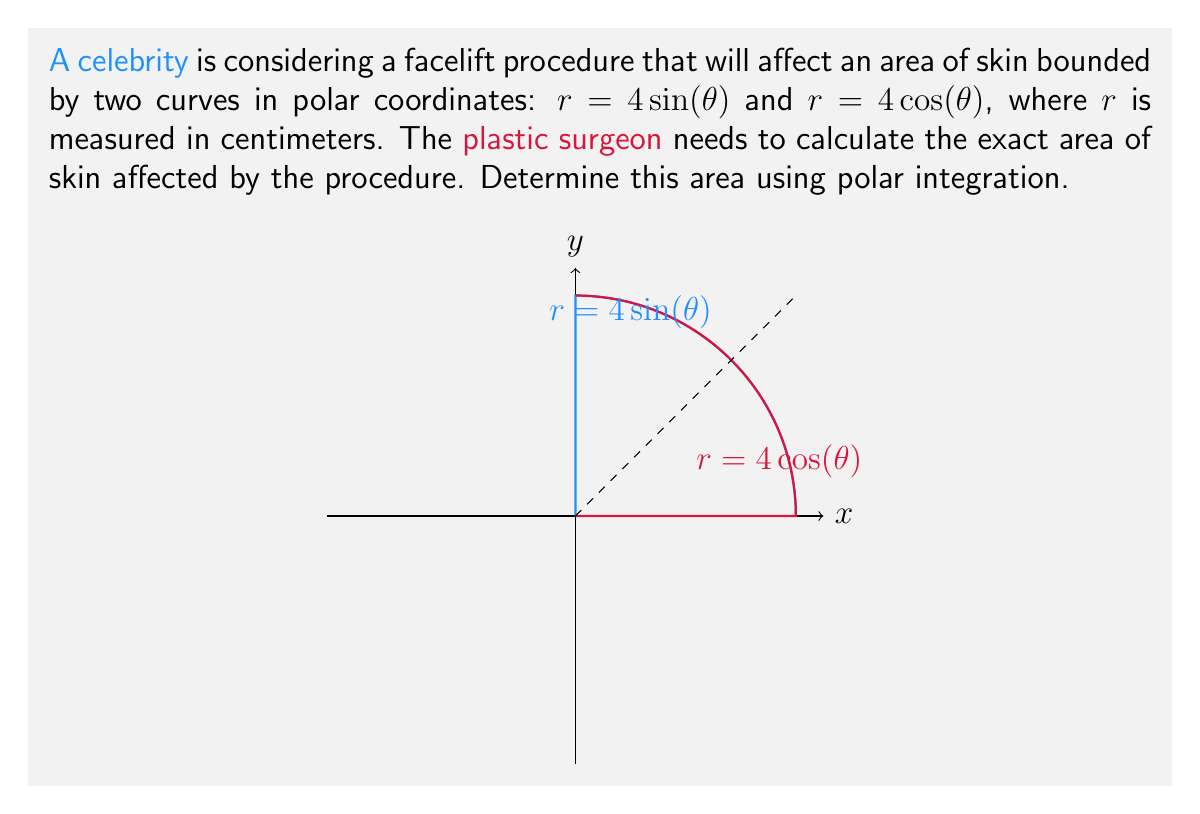Give your solution to this math problem. To find the area bounded by these curves, we'll use the formula for area in polar coordinates:

$$A = \frac{1}{2} \int_a^b [r(\theta)]^2 d\theta$$

where $r(\theta)$ is the outer curve minus the inner curve.

Step 1: Determine the limits of integration.
The curves intersect when $\sin(\theta) = \cos(\theta)$, which occurs at $\theta = \frac{\pi}{4}$. The area we're interested in is from $\theta = 0$ to $\theta = \frac{\pi}{4}$.

Step 2: Set up the integral.
$$A = \frac{1}{2} \int_0^{\frac{\pi}{4}} [(4\cos(\theta))^2 - (4\sin(\theta))^2] d\theta$$

Step 3: Simplify the integrand.
$$A = 8 \int_0^{\frac{\pi}{4}} [\cos^2(\theta) - \sin^2(\theta)] d\theta$$

Step 4: Recognize the double angle formula: $\cos^2(\theta) - \sin^2(\theta) = \cos(2\theta)$
$$A = 8 \int_0^{\frac{\pi}{4}} \cos(2\theta) d\theta$$

Step 5: Integrate.
$$A = 8 \cdot \frac{1}{2} \sin(2\theta) \Big|_0^{\frac{\pi}{4}} = 4 \sin(\frac{\pi}{2}) - 4 \sin(0) = 4 \text{ cm}^2$$

Therefore, the area of skin affected by the facelift procedure is 4 square centimeters.
Answer: $4 \text{ cm}^2$ 